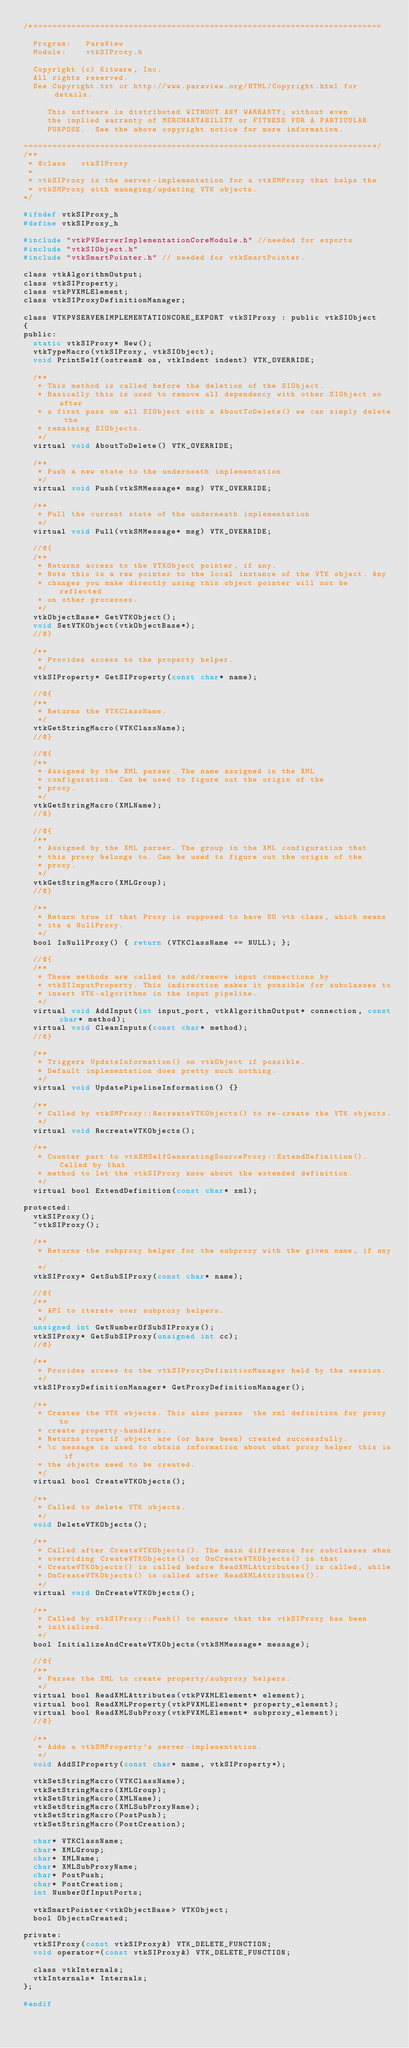Convert code to text. <code><loc_0><loc_0><loc_500><loc_500><_C_>/*=========================================================================

  Program:   ParaView
  Module:    vtkSIProxy.h

  Copyright (c) Kitware, Inc.
  All rights reserved.
  See Copyright.txt or http://www.paraview.org/HTML/Copyright.html for details.

     This software is distributed WITHOUT ANY WARRANTY; without even
     the implied warranty of MERCHANTABILITY or FITNESS FOR A PARTICULAR
     PURPOSE.  See the above copyright notice for more information.

=========================================================================*/
/**
 * @class   vtkSIProxy
 *
 * vtkSIProxy is the server-implementation for a vtkSMProxy that helps the
 * vtkSMProxy with managing/updating VTK objects.
*/

#ifndef vtkSIProxy_h
#define vtkSIProxy_h

#include "vtkPVServerImplementationCoreModule.h" //needed for exports
#include "vtkSIObject.h"
#include "vtkSmartPointer.h" // needed for vtkSmartPointer.

class vtkAlgorithmOutput;
class vtkSIProperty;
class vtkPVXMLElement;
class vtkSIProxyDefinitionManager;

class VTKPVSERVERIMPLEMENTATIONCORE_EXPORT vtkSIProxy : public vtkSIObject
{
public:
  static vtkSIProxy* New();
  vtkTypeMacro(vtkSIProxy, vtkSIObject);
  void PrintSelf(ostream& os, vtkIndent indent) VTK_OVERRIDE;

  /**
   * This method is called before the deletion of the SIObject.
   * Basically this is used to remove all dependency with other SIObject so after
   * a first pass on all SIObject with a AboutToDelete() we can simply delete the
   * remaining SIObjects.
   */
  virtual void AboutToDelete() VTK_OVERRIDE;

  /**
   * Push a new state to the underneath implementation
   */
  virtual void Push(vtkSMMessage* msg) VTK_OVERRIDE;

  /**
   * Pull the current state of the underneath implementation
   */
  virtual void Pull(vtkSMMessage* msg) VTK_OVERRIDE;

  //@{
  /**
   * Returns access to the VTKObject pointer, if any.
   * Note this is a raw pointer to the local instance of the VTK object. Any
   * changes you make directly using this object pointer will not be reflected
   * on other processes.
   */
  vtkObjectBase* GetVTKObject();
  void SetVTKObject(vtkObjectBase*);
  //@}

  /**
   * Provides access to the property helper.
   */
  vtkSIProperty* GetSIProperty(const char* name);

  //@{
  /**
   * Returns the VTKClassName.
   */
  vtkGetStringMacro(VTKClassName);
  //@}

  //@{
  /**
   * Assigned by the XML parser. The name assigned in the XML
   * configuration. Can be used to figure out the origin of the
   * proxy.
   */
  vtkGetStringMacro(XMLName);
  //@}

  //@{
  /**
   * Assigned by the XML parser. The group in the XML configuration that
   * this proxy belongs to. Can be used to figure out the origin of the
   * proxy.
   */
  vtkGetStringMacro(XMLGroup);
  //@}

  /**
   * Return true if that Proxy is supposed to have NO vtk class, which means
   * its a NullProxy.
   */
  bool IsNullProxy() { return (VTKClassName == NULL); };

  //@{
  /**
   * These methods are called to add/remove input connections by
   * vtkSIInputProperty. This indirection makes it possible for subclasses to
   * insert VTK-algorithms in the input pipeline.
   */
  virtual void AddInput(int input_port, vtkAlgorithmOutput* connection, const char* method);
  virtual void CleanInputs(const char* method);
  //@}

  /**
   * Triggers UpdateInformation() on vtkObject if possible.
   * Default implementation does pretty much nothing.
   */
  virtual void UpdatePipelineInformation() {}

  /**
   * Called by vtkSMProxy::RecreateVTKObjects() to re-create the VTK objects.
   */
  virtual void RecreateVTKObjects();

  /**
   * Counter part to vtkSMSelfGeneratingSourceProxy::ExtendDefinition(). Called by that
   * method to let the vtkSIProxy know about the extended definition.
   */
  virtual bool ExtendDefinition(const char* xml);

protected:
  vtkSIProxy();
  ~vtkSIProxy();

  /**
   * Returns the subproxy helper for the subproxy with the given name, if any.
   */
  vtkSIProxy* GetSubSIProxy(const char* name);

  //@{
  /**
   * API to iterate over subproxy helpers.
   */
  unsigned int GetNumberOfSubSIProxys();
  vtkSIProxy* GetSubSIProxy(unsigned int cc);
  //@}

  /**
   * Provides access to the vtkSIProxyDefinitionManager held by the session.
   */
  vtkSIProxyDefinitionManager* GetProxyDefinitionManager();

  /**
   * Creates the VTK objects. This also parses  the xml definition for proxy to
   * create property-handlers.
   * Returns true if object are (or have been) created successfully.
   * \c message is used to obtain information about what proxy helper this is if
   * the objects need to be created.
   */
  virtual bool CreateVTKObjects();

  /**
   * Called to delete VTK objects.
   */
  void DeleteVTKObjects();

  /**
   * Called after CreateVTKObjects(). The main difference for subclasses when
   * overriding CreateVTKObjects() or OnCreateVTKObjects() is that
   * CreateVTKObjects() is called before ReadXMLAttributes() is called, while
   * OnCreateVTKObjects() is called after ReadXMLAttributes().
   */
  virtual void OnCreateVTKObjects();

  /**
   * Called by vtkSIProxy::Push() to ensure that the vtkSIProxy has been
   * initialized.
   */
  bool InitializeAndCreateVTKObjects(vtkSMMessage* message);

  //@{
  /**
   * Parses the XML to create property/subproxy helpers.
   */
  virtual bool ReadXMLAttributes(vtkPVXMLElement* element);
  virtual bool ReadXMLProperty(vtkPVXMLElement* property_element);
  virtual bool ReadXMLSubProxy(vtkPVXMLElement* subproxy_element);
  //@}

  /**
   * Adds a vtkSMProperty's server-implementation.
   */
  void AddSIProperty(const char* name, vtkSIProperty*);

  vtkSetStringMacro(VTKClassName);
  vtkSetStringMacro(XMLGroup);
  vtkSetStringMacro(XMLName);
  vtkSetStringMacro(XMLSubProxyName);
  vtkSetStringMacro(PostPush);
  vtkSetStringMacro(PostCreation);

  char* VTKClassName;
  char* XMLGroup;
  char* XMLName;
  char* XMLSubProxyName;
  char* PostPush;
  char* PostCreation;
  int NumberOfInputPorts;

  vtkSmartPointer<vtkObjectBase> VTKObject;
  bool ObjectsCreated;

private:
  vtkSIProxy(const vtkSIProxy&) VTK_DELETE_FUNCTION;
  void operator=(const vtkSIProxy&) VTK_DELETE_FUNCTION;

  class vtkInternals;
  vtkInternals* Internals;
};

#endif
</code> 